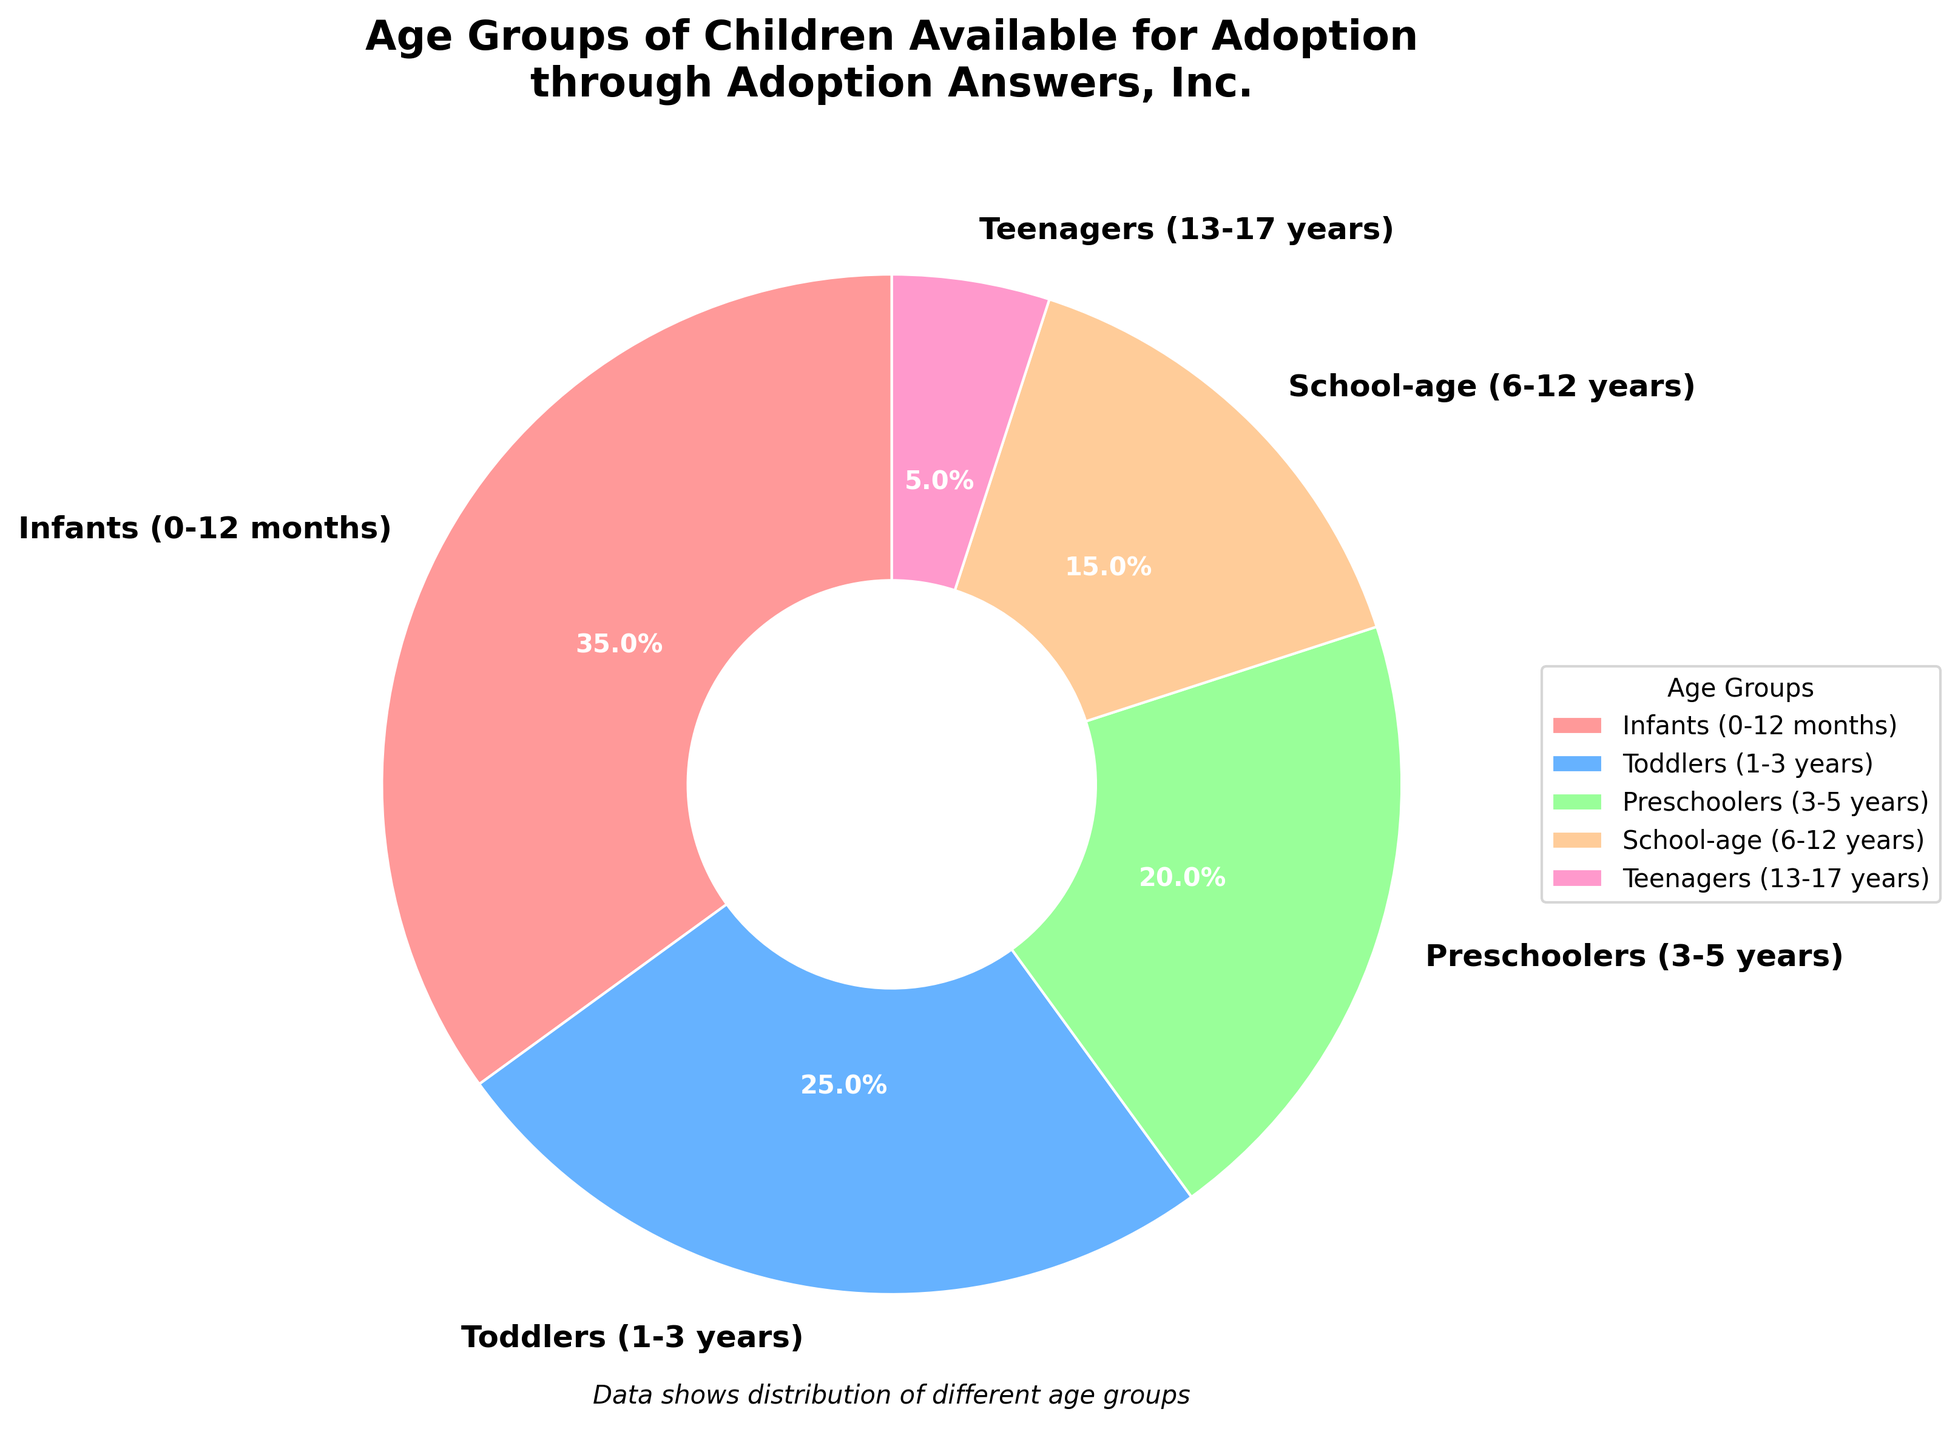Which age group has the largest percentage of children available for adoption? The chart shows different age groups and their corresponding percentages. The largest wedge corresponds to Infants (0-12 months) with 35%.
Answer: Infants (0-12 months) Which age group has the smallest percentage of children available for adoption? The smallest wedge in the pie chart corresponds to Teenagers (13-17 years) with 5%.
Answer: Teenagers (13-17 years) What is the combined percentage of children available in the age groups School-age and Teenagers? To find the combined percentage, add the percentage for School-age (6-12 years) and Teenagers (13-17 years). School-age is 15% and Teenagers is 5%, which gives 15% + 5% = 20%.
Answer: 20% How does the percentage of Toddlers compare to the percentage of Preschoolers? The chart shows Toddlers (1-3 years) with 25% and Preschoolers (3-5 years) with 20%. Toddlers have a higher percentage by 5%.
Answer: Toddlers What is the difference in percentage between Infants and Teenagers? Infants (0-12 months) have 35% and Teenagers (13-17 years) have 5%. The difference is 35% - 5% = 30%.
Answer: 30% Which age group has a percentage value closest to the average percentage of all groups? The total percentage is 100% and there are 5 age groups, so the average is 100% / 5 = 20%. Preschoolers (3-5 years) have a percentage of 20%, which matches the average.
Answer: Preschoolers (3-5 years) Which color represents the percentage of Toddlers in the chart? In the pie chart, the wedge for Toddlers (1-3 years) is colored blue.
Answer: Blue If the percentage of Infants increased by 10%, what would be the new percentage? Currently, Infants (0-12 months) are at 35%. Adding 10% to 35% results in 35% + 10% = 45%.
Answer: 45% What is the difference between the percentages of Toddlers and School-age children? The percentage for Toddlers (1-3 years) is 25%, and for School-age (6-12 years) it is 15%. The difference is 25% - 15% = 10%.
Answer: 10% Calculate the sum of the percentages for children under 6 years old. Infants (0-12 months) have 35%, Toddlers (1-3 years) have 25%, and Preschoolers (3-5 years) have 20%. The sum is 35% + 25% + 20% = 80%.
Answer: 80% 